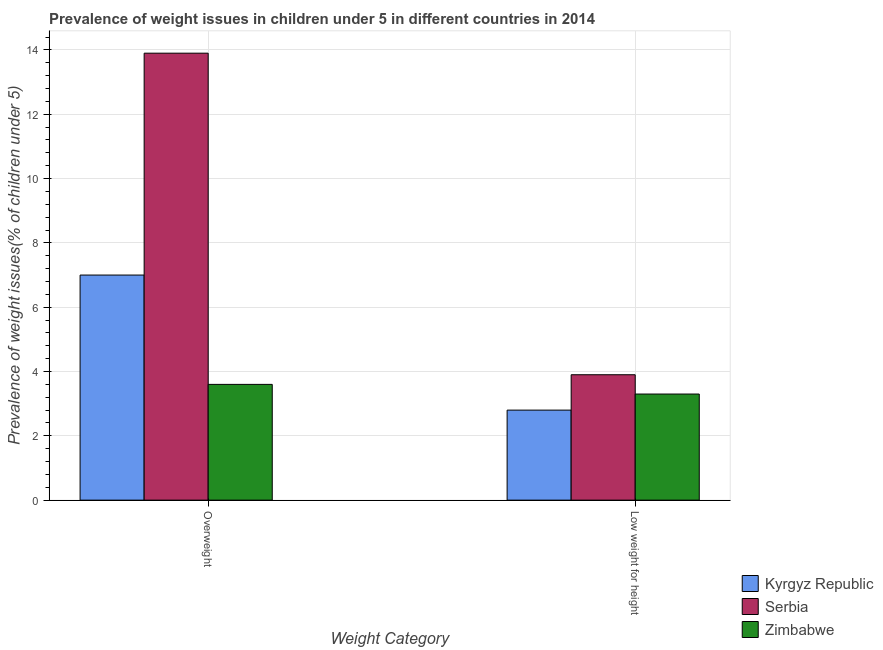How many bars are there on the 1st tick from the left?
Offer a very short reply. 3. How many bars are there on the 1st tick from the right?
Make the answer very short. 3. What is the label of the 2nd group of bars from the left?
Give a very brief answer. Low weight for height. What is the percentage of underweight children in Serbia?
Your answer should be very brief. 3.9. Across all countries, what is the maximum percentage of underweight children?
Your response must be concise. 3.9. Across all countries, what is the minimum percentage of underweight children?
Your response must be concise. 2.8. In which country was the percentage of overweight children maximum?
Give a very brief answer. Serbia. In which country was the percentage of overweight children minimum?
Provide a short and direct response. Zimbabwe. What is the total percentage of underweight children in the graph?
Provide a short and direct response. 10. What is the difference between the percentage of underweight children in Kyrgyz Republic and that in Serbia?
Offer a very short reply. -1.1. What is the difference between the percentage of overweight children in Kyrgyz Republic and the percentage of underweight children in Zimbabwe?
Offer a terse response. 3.7. What is the average percentage of underweight children per country?
Make the answer very short. 3.33. What is the difference between the percentage of underweight children and percentage of overweight children in Kyrgyz Republic?
Your answer should be compact. -4.2. In how many countries, is the percentage of underweight children greater than 9.6 %?
Offer a very short reply. 0. What is the ratio of the percentage of underweight children in Zimbabwe to that in Kyrgyz Republic?
Your answer should be compact. 1.18. What does the 3rd bar from the left in Overweight represents?
Provide a short and direct response. Zimbabwe. What does the 3rd bar from the right in Low weight for height represents?
Your answer should be very brief. Kyrgyz Republic. How many bars are there?
Make the answer very short. 6. Are all the bars in the graph horizontal?
Your response must be concise. No. What is the difference between two consecutive major ticks on the Y-axis?
Offer a very short reply. 2. How many legend labels are there?
Your answer should be compact. 3. What is the title of the graph?
Provide a short and direct response. Prevalence of weight issues in children under 5 in different countries in 2014. What is the label or title of the X-axis?
Ensure brevity in your answer.  Weight Category. What is the label or title of the Y-axis?
Offer a very short reply. Prevalence of weight issues(% of children under 5). What is the Prevalence of weight issues(% of children under 5) in Kyrgyz Republic in Overweight?
Make the answer very short. 7. What is the Prevalence of weight issues(% of children under 5) in Serbia in Overweight?
Ensure brevity in your answer.  13.9. What is the Prevalence of weight issues(% of children under 5) in Zimbabwe in Overweight?
Offer a terse response. 3.6. What is the Prevalence of weight issues(% of children under 5) of Kyrgyz Republic in Low weight for height?
Your answer should be very brief. 2.8. What is the Prevalence of weight issues(% of children under 5) in Serbia in Low weight for height?
Your answer should be compact. 3.9. What is the Prevalence of weight issues(% of children under 5) in Zimbabwe in Low weight for height?
Offer a terse response. 3.3. Across all Weight Category, what is the maximum Prevalence of weight issues(% of children under 5) of Kyrgyz Republic?
Keep it short and to the point. 7. Across all Weight Category, what is the maximum Prevalence of weight issues(% of children under 5) in Serbia?
Your answer should be very brief. 13.9. Across all Weight Category, what is the maximum Prevalence of weight issues(% of children under 5) of Zimbabwe?
Your answer should be very brief. 3.6. Across all Weight Category, what is the minimum Prevalence of weight issues(% of children under 5) of Kyrgyz Republic?
Your answer should be very brief. 2.8. Across all Weight Category, what is the minimum Prevalence of weight issues(% of children under 5) in Serbia?
Your response must be concise. 3.9. Across all Weight Category, what is the minimum Prevalence of weight issues(% of children under 5) of Zimbabwe?
Make the answer very short. 3.3. What is the total Prevalence of weight issues(% of children under 5) in Kyrgyz Republic in the graph?
Keep it short and to the point. 9.8. What is the total Prevalence of weight issues(% of children under 5) of Serbia in the graph?
Offer a very short reply. 17.8. What is the total Prevalence of weight issues(% of children under 5) in Zimbabwe in the graph?
Offer a terse response. 6.9. What is the difference between the Prevalence of weight issues(% of children under 5) of Kyrgyz Republic in Overweight and that in Low weight for height?
Keep it short and to the point. 4.2. What is the difference between the Prevalence of weight issues(% of children under 5) of Zimbabwe in Overweight and that in Low weight for height?
Your response must be concise. 0.3. What is the difference between the Prevalence of weight issues(% of children under 5) in Kyrgyz Republic in Overweight and the Prevalence of weight issues(% of children under 5) in Serbia in Low weight for height?
Your answer should be very brief. 3.1. What is the difference between the Prevalence of weight issues(% of children under 5) in Serbia in Overweight and the Prevalence of weight issues(% of children under 5) in Zimbabwe in Low weight for height?
Offer a very short reply. 10.6. What is the average Prevalence of weight issues(% of children under 5) of Zimbabwe per Weight Category?
Ensure brevity in your answer.  3.45. What is the difference between the Prevalence of weight issues(% of children under 5) in Kyrgyz Republic and Prevalence of weight issues(% of children under 5) in Serbia in Overweight?
Make the answer very short. -6.9. What is the difference between the Prevalence of weight issues(% of children under 5) of Kyrgyz Republic and Prevalence of weight issues(% of children under 5) of Serbia in Low weight for height?
Provide a short and direct response. -1.1. What is the difference between the Prevalence of weight issues(% of children under 5) of Serbia and Prevalence of weight issues(% of children under 5) of Zimbabwe in Low weight for height?
Your answer should be compact. 0.6. What is the ratio of the Prevalence of weight issues(% of children under 5) in Serbia in Overweight to that in Low weight for height?
Provide a succinct answer. 3.56. What is the ratio of the Prevalence of weight issues(% of children under 5) in Zimbabwe in Overweight to that in Low weight for height?
Provide a short and direct response. 1.09. What is the difference between the highest and the second highest Prevalence of weight issues(% of children under 5) of Kyrgyz Republic?
Keep it short and to the point. 4.2. What is the difference between the highest and the second highest Prevalence of weight issues(% of children under 5) in Zimbabwe?
Provide a short and direct response. 0.3. What is the difference between the highest and the lowest Prevalence of weight issues(% of children under 5) in Zimbabwe?
Provide a short and direct response. 0.3. 